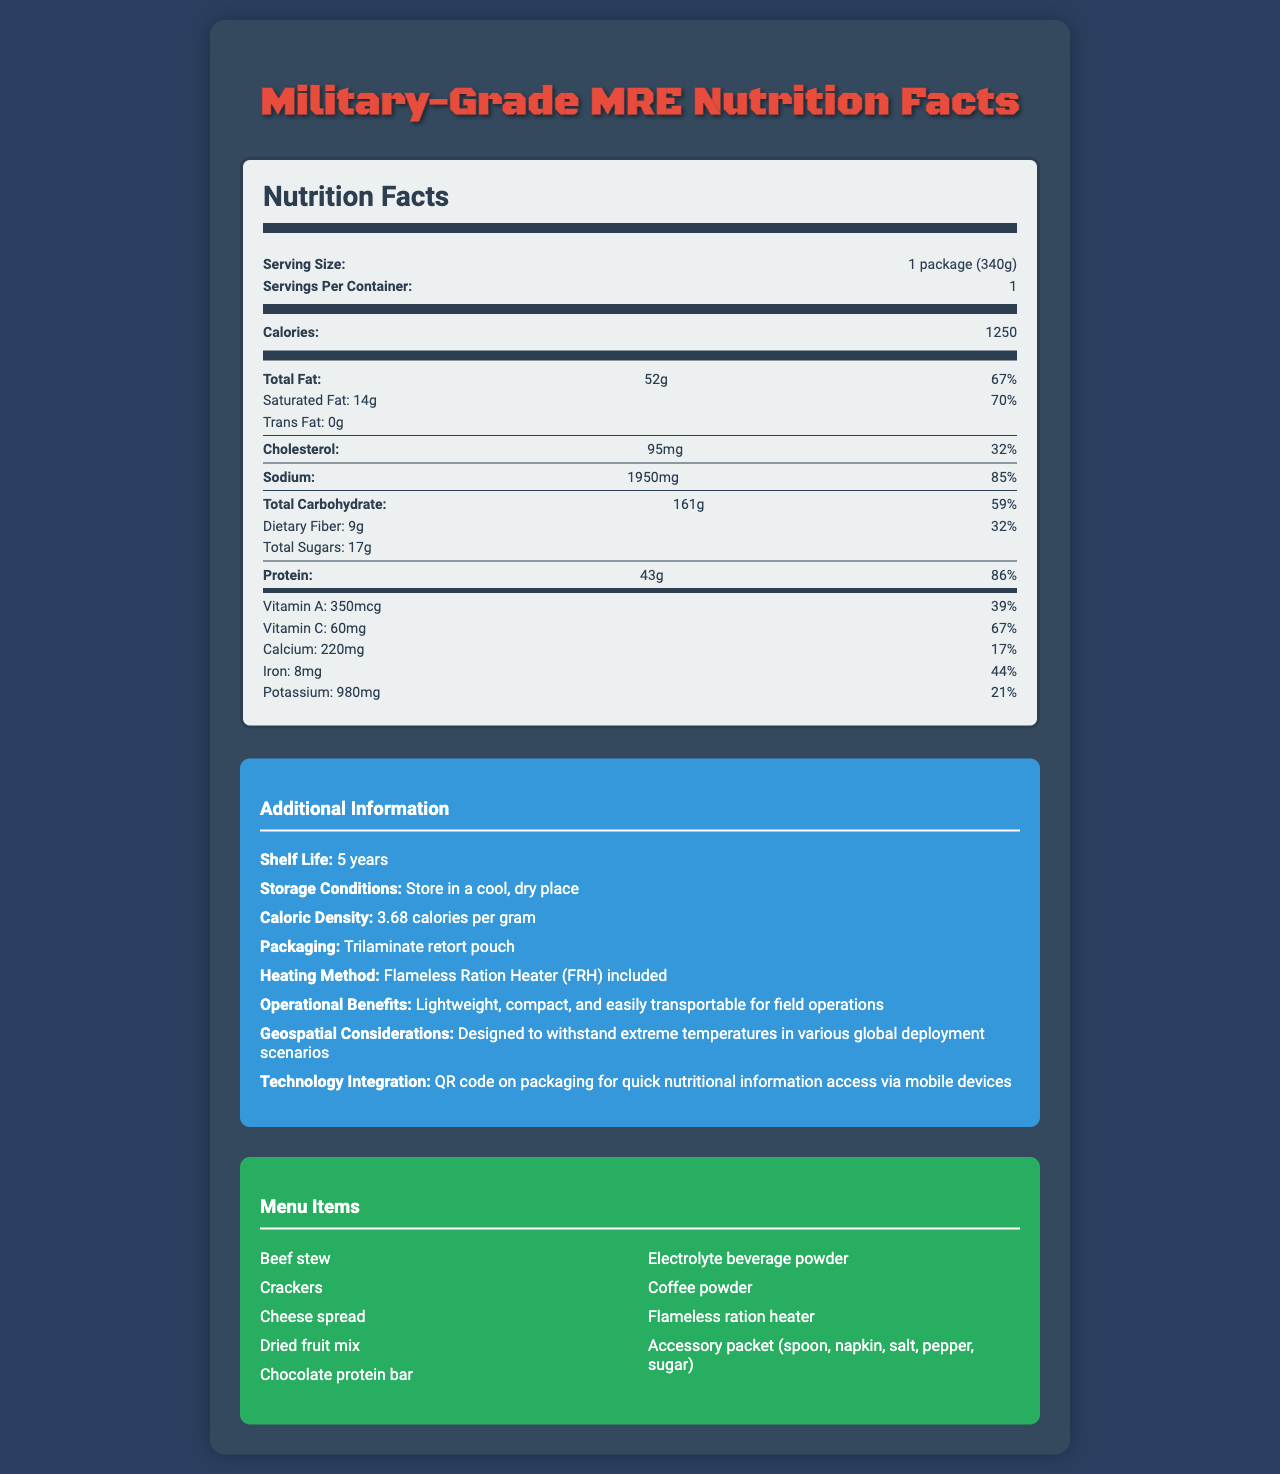what is the shelf life of the Military-Grade MRE: Beef Stew? The shelf life is listed under the "Additional Information" section, stating it is 5 years.
Answer: 5 years What is the caloric density of the Military-Grade MRE: Beef Stew? The caloric density is mentioned in the "Additional Information" section stating 3.68 calories per gram.
Answer: 3.68 calories per gram How many calories does one package of the Military-Grade MRE: Beef Stew have? The calories per package are listed under "Nutrition Facts," showing 1250 calories.
Answer: 1250 What are the total carbohydrates in one package of the Military-Grade MRE: Beef Stew? The total carbohydrates are specified in the "Nutrition Facts" section as 161g.
Answer: 161g How much protein is in one serving of Military-Grade MRE: Beef Stew? The amount of protein is listed under "Nutrition Facts" and reads 43g of protein.
Answer: 43g What packaging material is used for the Military-Grade MRE: Beef Stew? The packaging material is mentioned in the "Additional Information" section as "Trilaminate retort pouch."
Answer: Trilaminate retort pouch What heating method is included with the Military-Grade MRE: Beef Stew? A. Stove B. Flameless Ration Heater (FRH) C. Microwave The heating method listed under "Additional Information" is the Flameless Ration Heater (FRH).
Answer: B How much saturated fat is in a serving of Military-Grade MRE: Beef Stew? A. 10g B. 14g C. 18g D. 20g According to the "Nutrition Facts," the saturated fat content is 14g.
Answer: B Does the Military-Grade MRE: Beef Stew contain any trans fat? The "Nutrition Facts" indicate that the trans fat amount is 0g.
Answer: No Summarize the main dietary elements and considerations of the Military-Grade MRE: Beef Stew. The document lists the nutritional content, including high caloric density and essential nutrients. Shelf life, storage conditions, heating method, and packaging are also detailed, along with operational benefits and technology integration for military use.
Answer: The Military-Grade MRE: Beef Stew provides a high-calorie meal of 1250 calories per serving and includes significant amounts of protein (43g), carbohydrates (161g), and fat (52g). It is designed to be lightweight, compact, and suitable for various operational environments, with a shelf life of 5 years. The meal can be heated using a Flameless Ration Heater (FRH) and is packaged in a durable trilaminate retort pouch. Additional operational benefits and geospatial considerations are included to ensure its utility in different deployment scenarios. What is the sodium content per package of this MRE? Under "Nutrition Facts," the sodium content is listed as 1950mg.
Answer: 1950mg Does the accessory packet include a fork? The accessory packet contents listed don't mention a fork; only a spoon, napkin, salt, pepper, and sugar are included.
Answer: No Can you determine the exact production date of the Military-Grade MRE: Beef Stew? The document does not provide any information about the production date.
Answer: Not enough information 